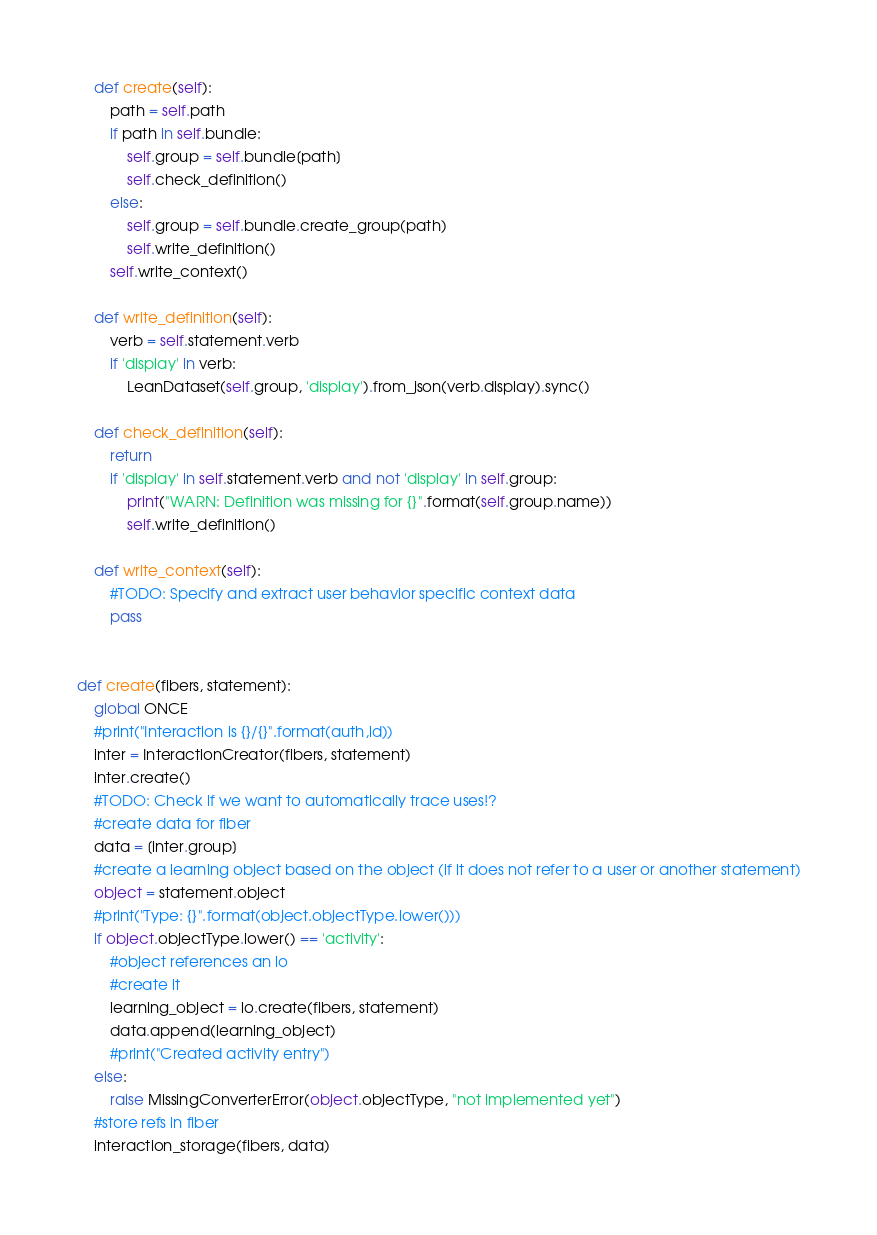Convert code to text. <code><loc_0><loc_0><loc_500><loc_500><_Python_>
    def create(self):
        path = self.path
        if path in self.bundle:
            self.group = self.bundle[path]
            self.check_definition()
        else:
            self.group = self.bundle.create_group(path)
            self.write_definition()
        self.write_context()

    def write_definition(self):
        verb = self.statement.verb
        if 'display' in verb:
            LeanDataset(self.group, 'display').from_json(verb.display).sync()

    def check_definition(self):
        return
        if 'display' in self.statement.verb and not 'display' in self.group:
            print("WARN: Definition was missing for {}".format(self.group.name))
            self.write_definition()
    
    def write_context(self):
        #TODO: Specify and extract user behavior specific context data
        pass


def create(fibers, statement):
    global ONCE
    #print("Interaction is {}/{}".format(auth,id))
    inter = InteractionCreator(fibers, statement)
    inter.create()
    #TODO: Check if we want to automatically trace uses!?
    #create data for fiber
    data = [inter.group]
    #create a learning object based on the object (if it does not refer to a user or another statement)
    object = statement.object
    #print("Type: {}".format(object.objectType.lower()))
    if object.objectType.lower() == 'activity':
        #object references an lo
        #create it
        learning_object = lo.create(fibers, statement)
        data.append(learning_object)
        #print("Created activity entry")
    else:
        raise MissingConverterError(object.objectType, "not implemented yet")
    #store refs in fiber
    interaction_storage(fibers, data)
</code> 